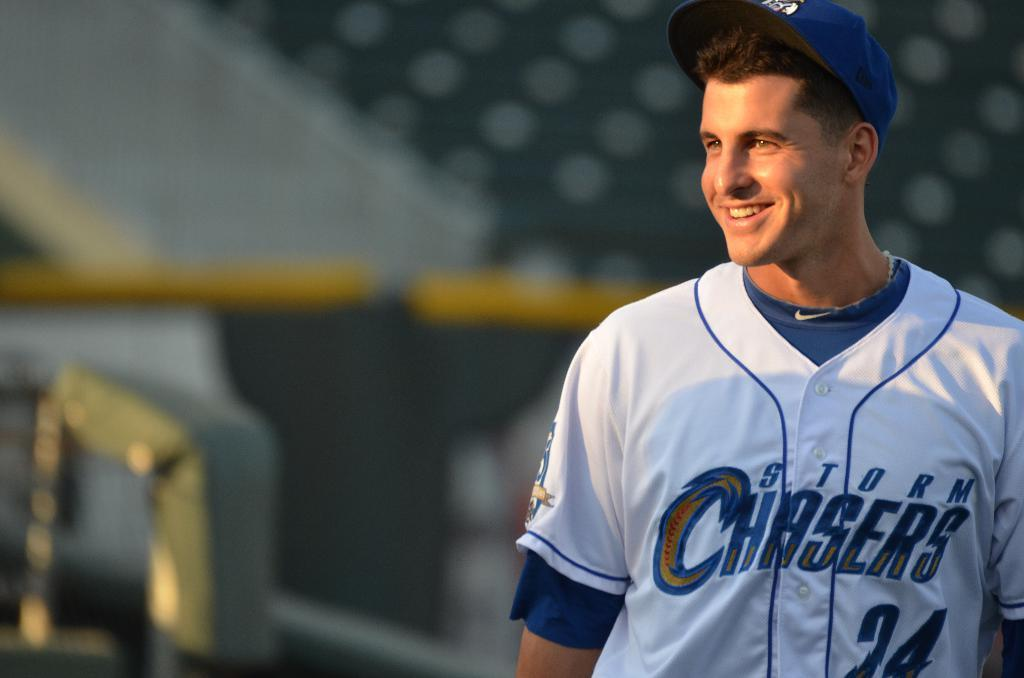<image>
Share a concise interpretation of the image provided. The player smiling plays for the storm chasers team. 